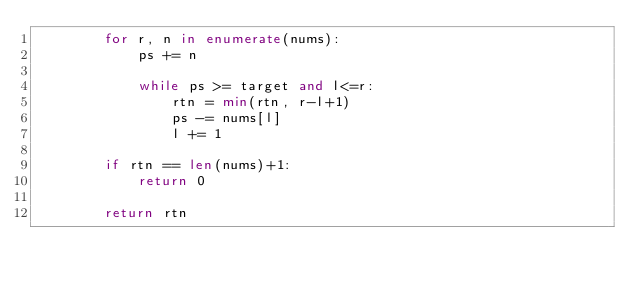<code> <loc_0><loc_0><loc_500><loc_500><_Python_>        for r, n in enumerate(nums):
            ps += n
            
            while ps >= target and l<=r:
                rtn = min(rtn, r-l+1)
                ps -= nums[l]
                l += 1
        
        if rtn == len(nums)+1:
            return 0
        
        return rtn
            </code> 